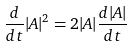<formula> <loc_0><loc_0><loc_500><loc_500>\frac { d } { d t } | A | ^ { 2 } = 2 | A | \frac { d | A | } { d t }</formula> 